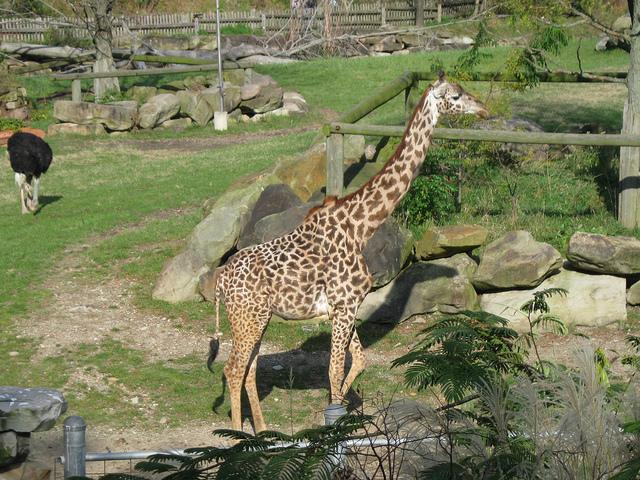Is the giraffe standing on grass?
Keep it brief. Yes. Is the giraffe taller than the rocks?
Answer briefly. Yes. How many posts?
Write a very short answer. 8. Which direction is the animal looking?
Concise answer only. Right. How long is the hair on the giraffe's neck and back?
Give a very brief answer. 2 inches. What direction is the giraffe facing?
Short answer required. Right. Overcast or sunny?
Be succinct. Sunny. How many giraffes are visible?
Write a very short answer. 1. What color are the rocks in the background?
Give a very brief answer. Gray. What animal is near the giraffe?
Short answer required. Ostrich. Is this photo taken in the wild?
Concise answer only. No. How many giraffes are there?
Be succinct. 1. 